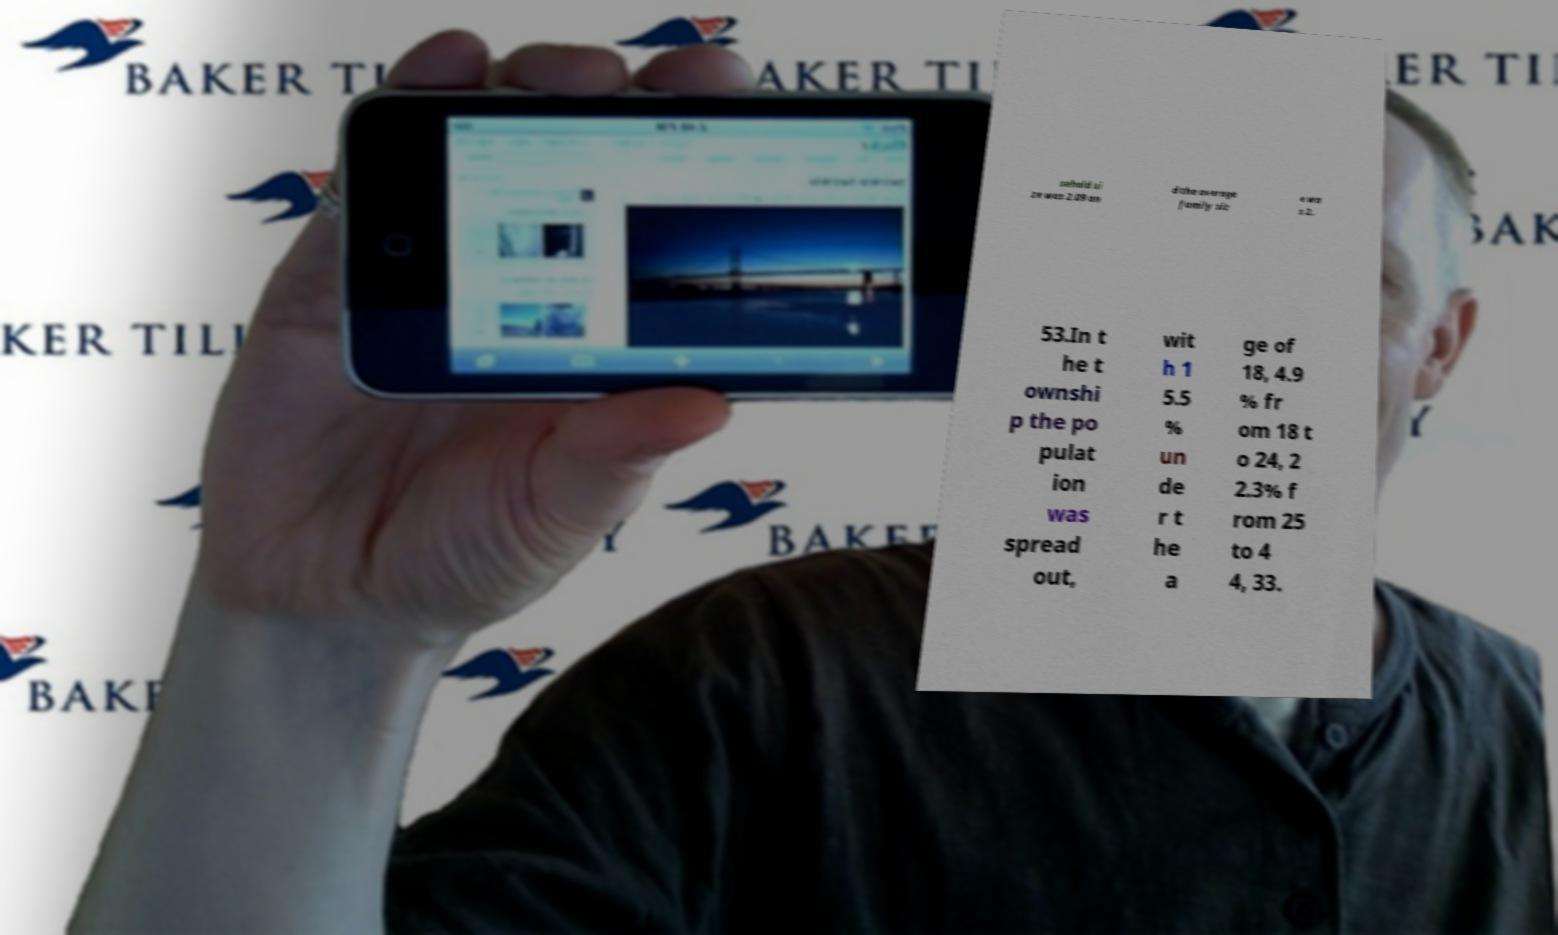What messages or text are displayed in this image? I need them in a readable, typed format. sehold si ze was 2.09 an d the average family siz e wa s 2. 53.In t he t ownshi p the po pulat ion was spread out, wit h 1 5.5 % un de r t he a ge of 18, 4.9 % fr om 18 t o 24, 2 2.3% f rom 25 to 4 4, 33. 